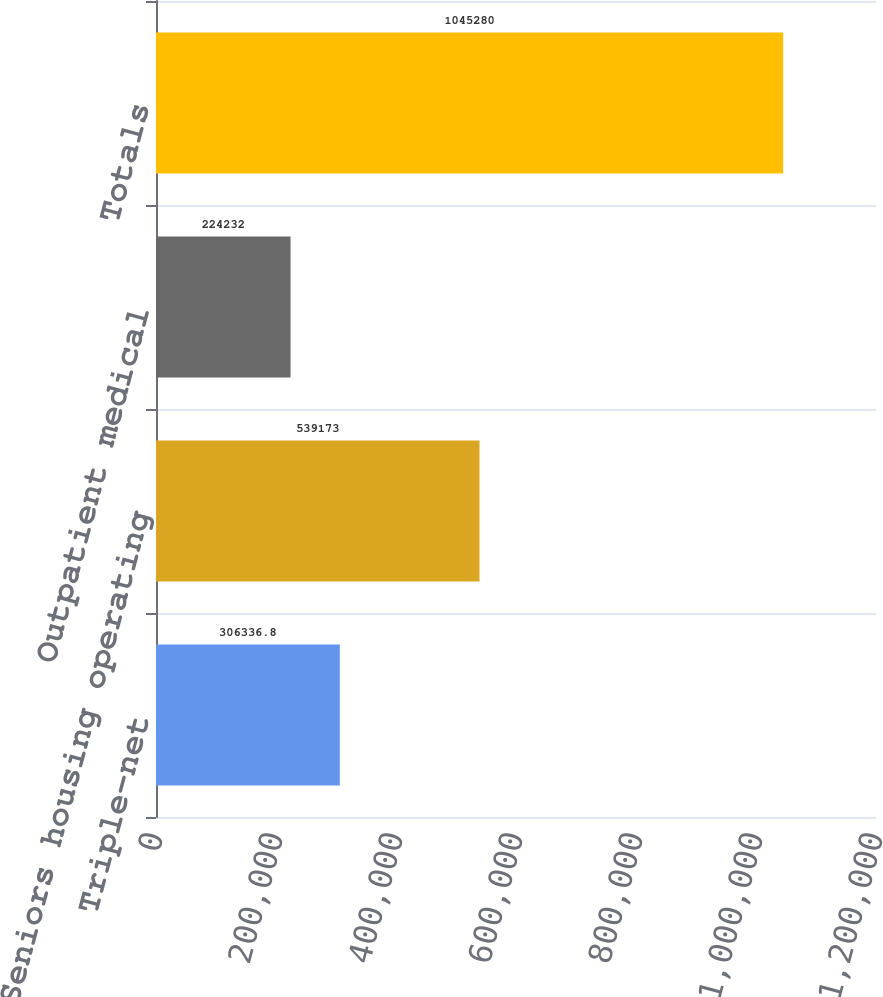<chart> <loc_0><loc_0><loc_500><loc_500><bar_chart><fcel>Triple-net<fcel>Seniors housing operating<fcel>Outpatient medical<fcel>Totals<nl><fcel>306337<fcel>539173<fcel>224232<fcel>1.04528e+06<nl></chart> 